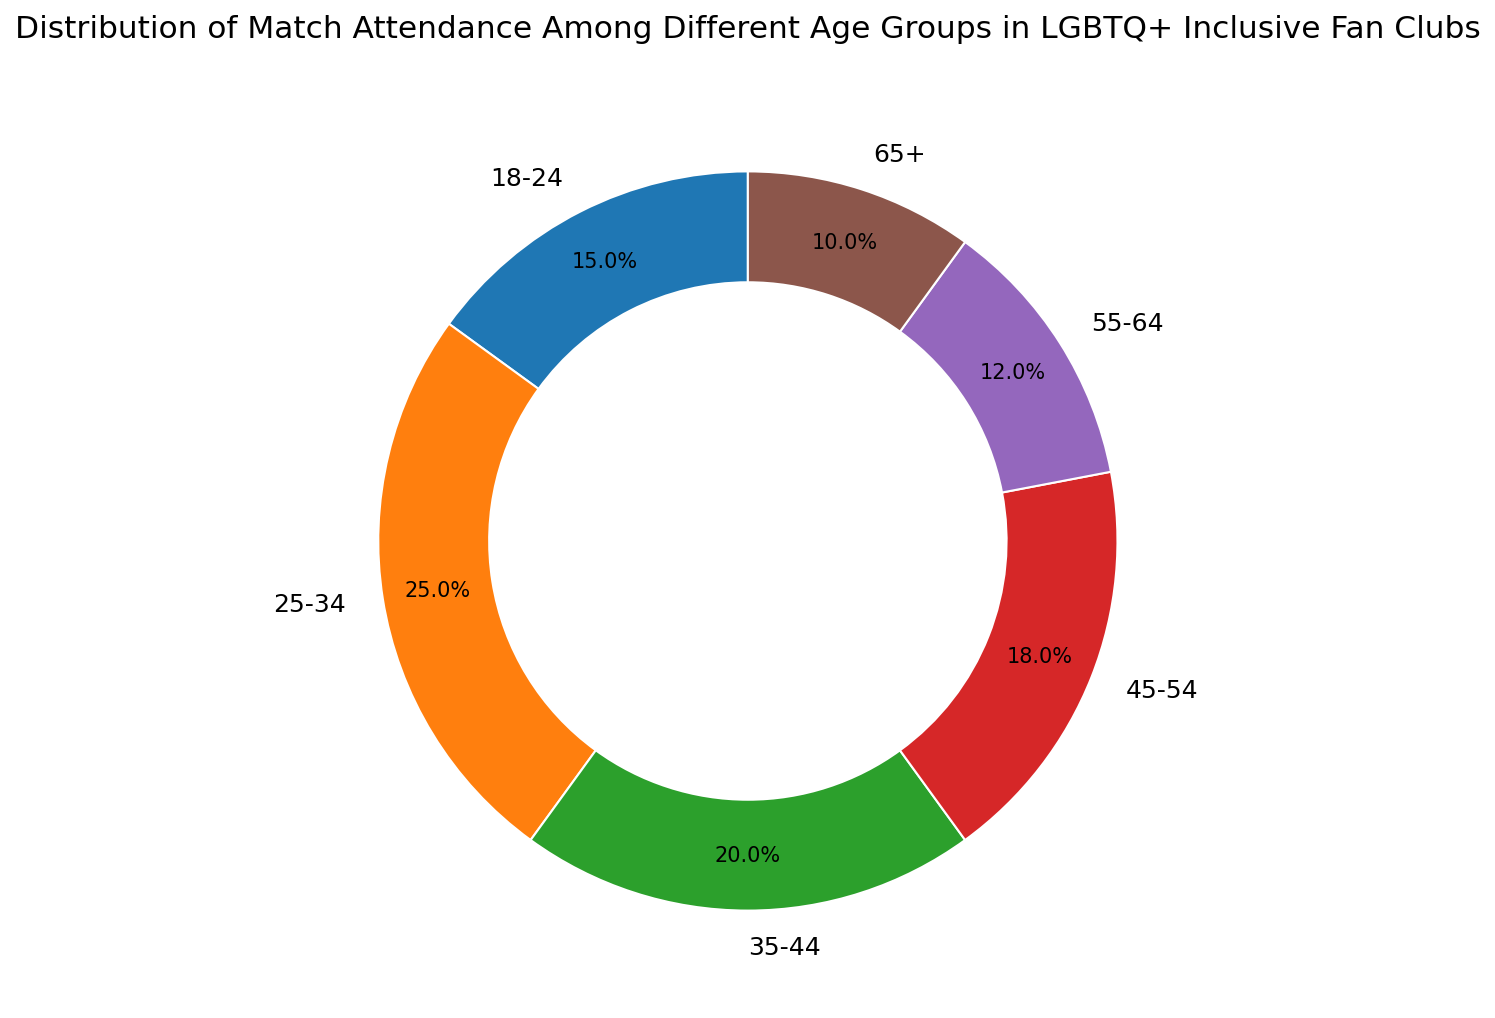what's the attendance percentage for the age group 25-34? Locate the segment labeled 25-34 on the ring chart. The percentage value within or next to it should read 25%.
Answer: 25% which age group has the smallest attendance percentage? Find the segment with the smallest portion of the ring. This corresponds to the age group 65+ with a percentage of 10%.
Answer: 65+ what is the combined attendance percentage for the age groups 18-24 and 65+? Identify the segments for 18-24 and 65+, which have percentages of 15% and 10% respectively. Add these values together: 15% + 10% = 25%.
Answer: 25% which age group has a higher attendance percentage: 35-44 or 45-54? Compare the segments for 35-44 and 45-54. The segment labeled 35-44 shows 20%, while 45-54 shows 18%. 35-44 has a higher percentage.
Answer: 35-44 what is the difference in attendance percentage between the age groups 25-34 and 55-64? Locate the segments for 25-34 and 55-64, which show percentages of 25% and 12% respectively. Subtract the smaller percentage from the larger one: 25% - 12% = 13%.
Answer: 13% are there more attendees in the age group 45-54 or 55-64? Compare the segments for 45-54 and 55-64. The segment labeled 45-54 shows 18%, while 55-64 shows 12%. 45-54 has more attendees.
Answer: 45-54 what is the total attendance percentage for all age groups below 35 years? Find the segments for 18-24 and 25-34, which have percentages of 15% and 25% respectively. Add these values together: 15% + 25% = 40%.
Answer: 40% which age group has twice the attendance percentage of the 65+ age group? The segment for 65+ shows 10%. The age group with twice this percentage is 20%. Locate the segment that shows 20%, which corresponds to the 35-44 age group.
Answer: 35-44 how many age groups have an attendance percentage above 20%? Identify the segments with percentages greater than 20%. The age groups 25-34 (25%) and 35-44 (20%) fit this criteria. Note that only 25-34 is strictly greater than 20%.
Answer: 1 